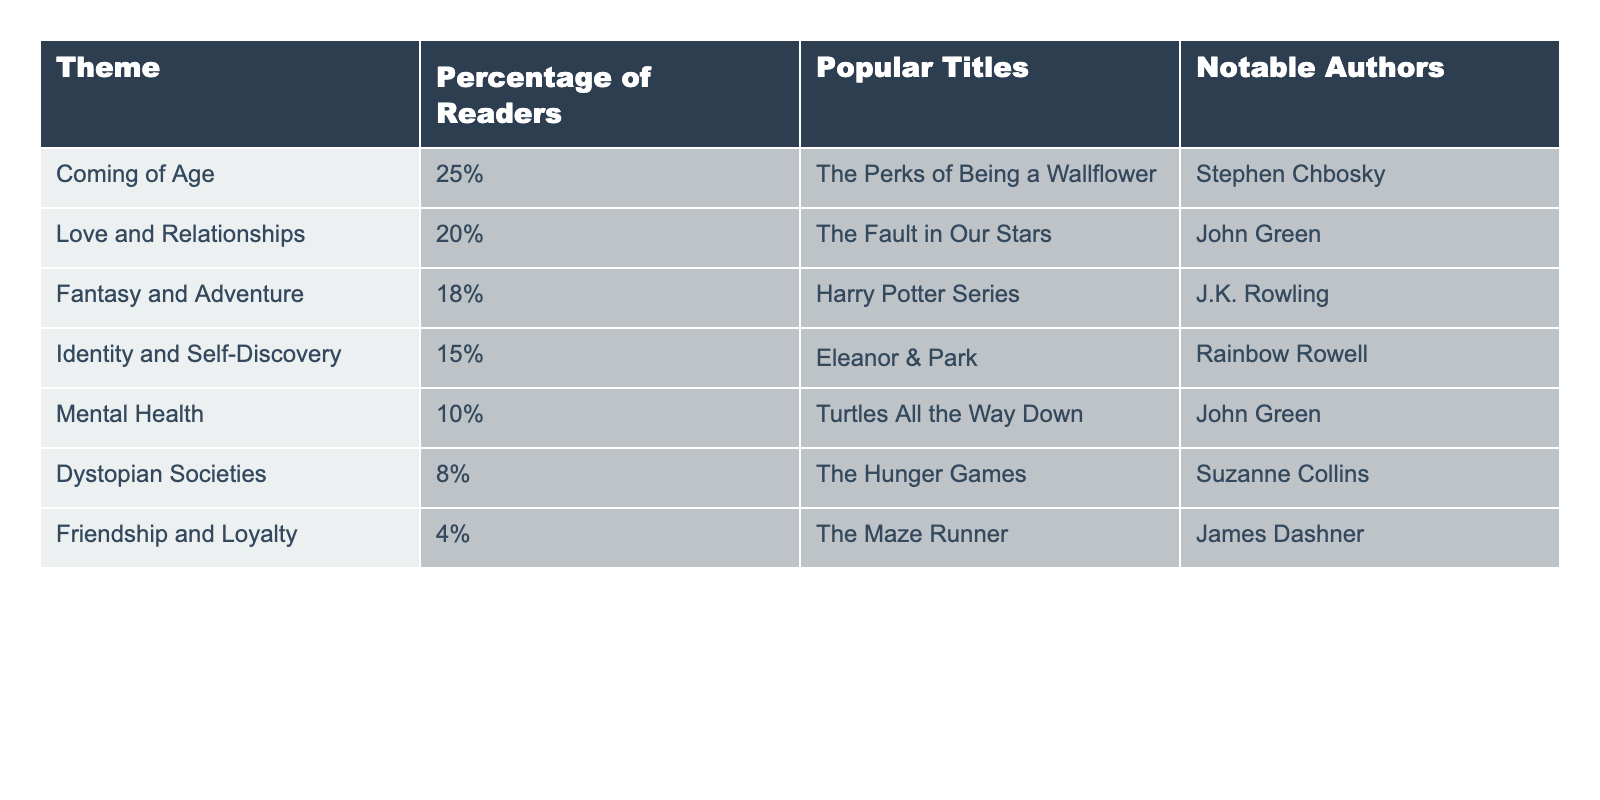What is the most popular theme in young adult fiction? The table shows that "Coming of Age" has the highest percentage at 25%, making it the most popular theme among readers.
Answer: Coming of Age Which theme has a lower percentage: Dystopian Societies or Friendship and Loyalty? Dystopian Societies has 8%, while Friendship and Loyalty has 4%. Since 4% is lower than 8%, Friendship and Loyalty has the lower percentage.
Answer: Friendship and Loyalty How many themes have a percentage of 15% or more? The themes with 15% or more are Coming of Age (25%), Love and Relationships (20%), Fantasy and Adventure (18%), and Identity and Self-Discovery (15%). That totals 4 themes.
Answer: 4 What percentage of readers enjoy Mental Health themes compared to Fantasy and Adventure? Mental Health has 10%, and Fantasy and Adventure has 18%. Since 18% is greater than 10%, Fantasy and Adventure is enjoyed by a higher percentage of readers.
Answer: Fantasy and Adventure Is "The Fault in Our Stars" associated with the theme of Identity and Self-Discovery? "The Fault in Our Stars" is listed under the Love and Relationships theme, not under Identity and Self-Discovery. Therefore, it is not associated with that theme.
Answer: No What is the difference in percentage between the most popular theme and the least popular theme? The most popular theme, Coming of Age, is at 25%, while the least popular theme, Friendship and Loyalty, is at 4%. The difference is 25% - 4% = 21%.
Answer: 21% Which author is associated with the second most popular theme? The second most popular theme is Love and Relationships at 20%, which is associated with the author John Green.
Answer: John Green What themes have percentages less than 10%? The only theme with a percentage less than 10% is Friendship and Loyalty at 4% and Dystopian Societies at 8%. Therefore, both of these themes apply.
Answer: Friendship and Loyalty, Dystopian Societies How many notable authors are listed in the table? The notable authors listed are Stephen Chbosky, John Green, J.K. Rowling, Rainbow Rowell, and Suzanne Collins, totaling 5 authors.
Answer: 5 What theme represents the least interest among readers? The theme with the least interest among readers is Friendship and Loyalty, with a percentage of 4%.
Answer: Friendship and Loyalty 